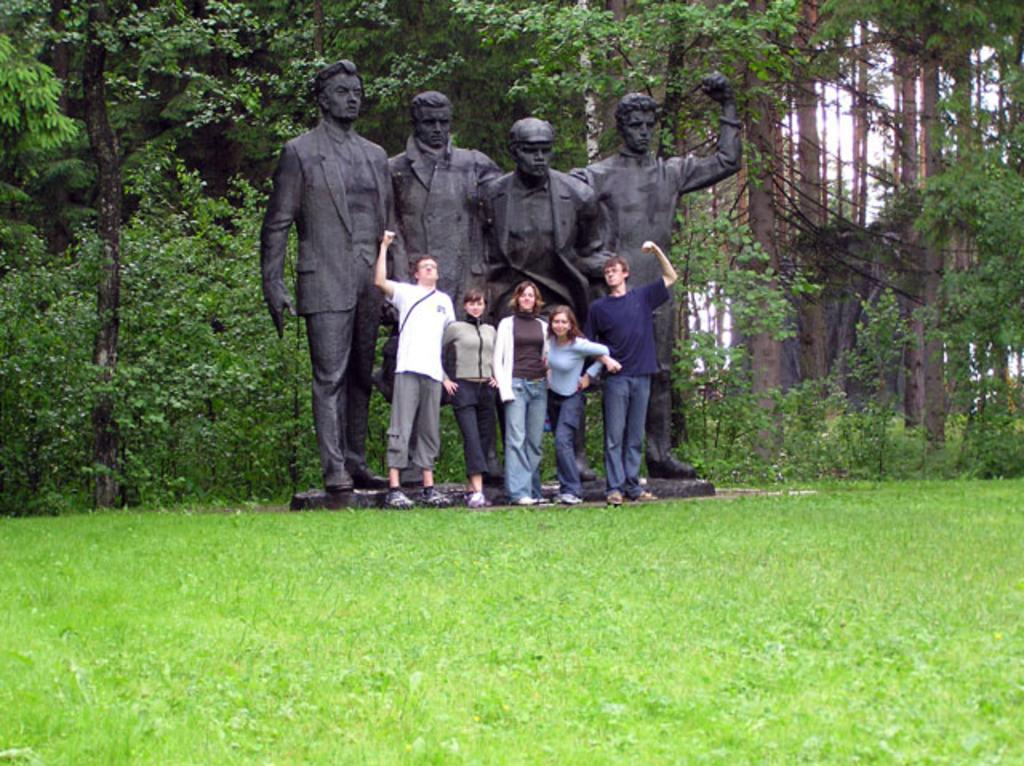What type of vegetation is present on the ground in the front of the image? There is grass on the ground in the front of the image. What can be seen in the center of the image? There are persons standing and statues in the center of the image. What is visible in the background of the image? There are trees in the background of the image. What type of belief is depicted by the worm in the image? There is no worm present in the image, so it is not possible to determine any beliefs associated with it. 